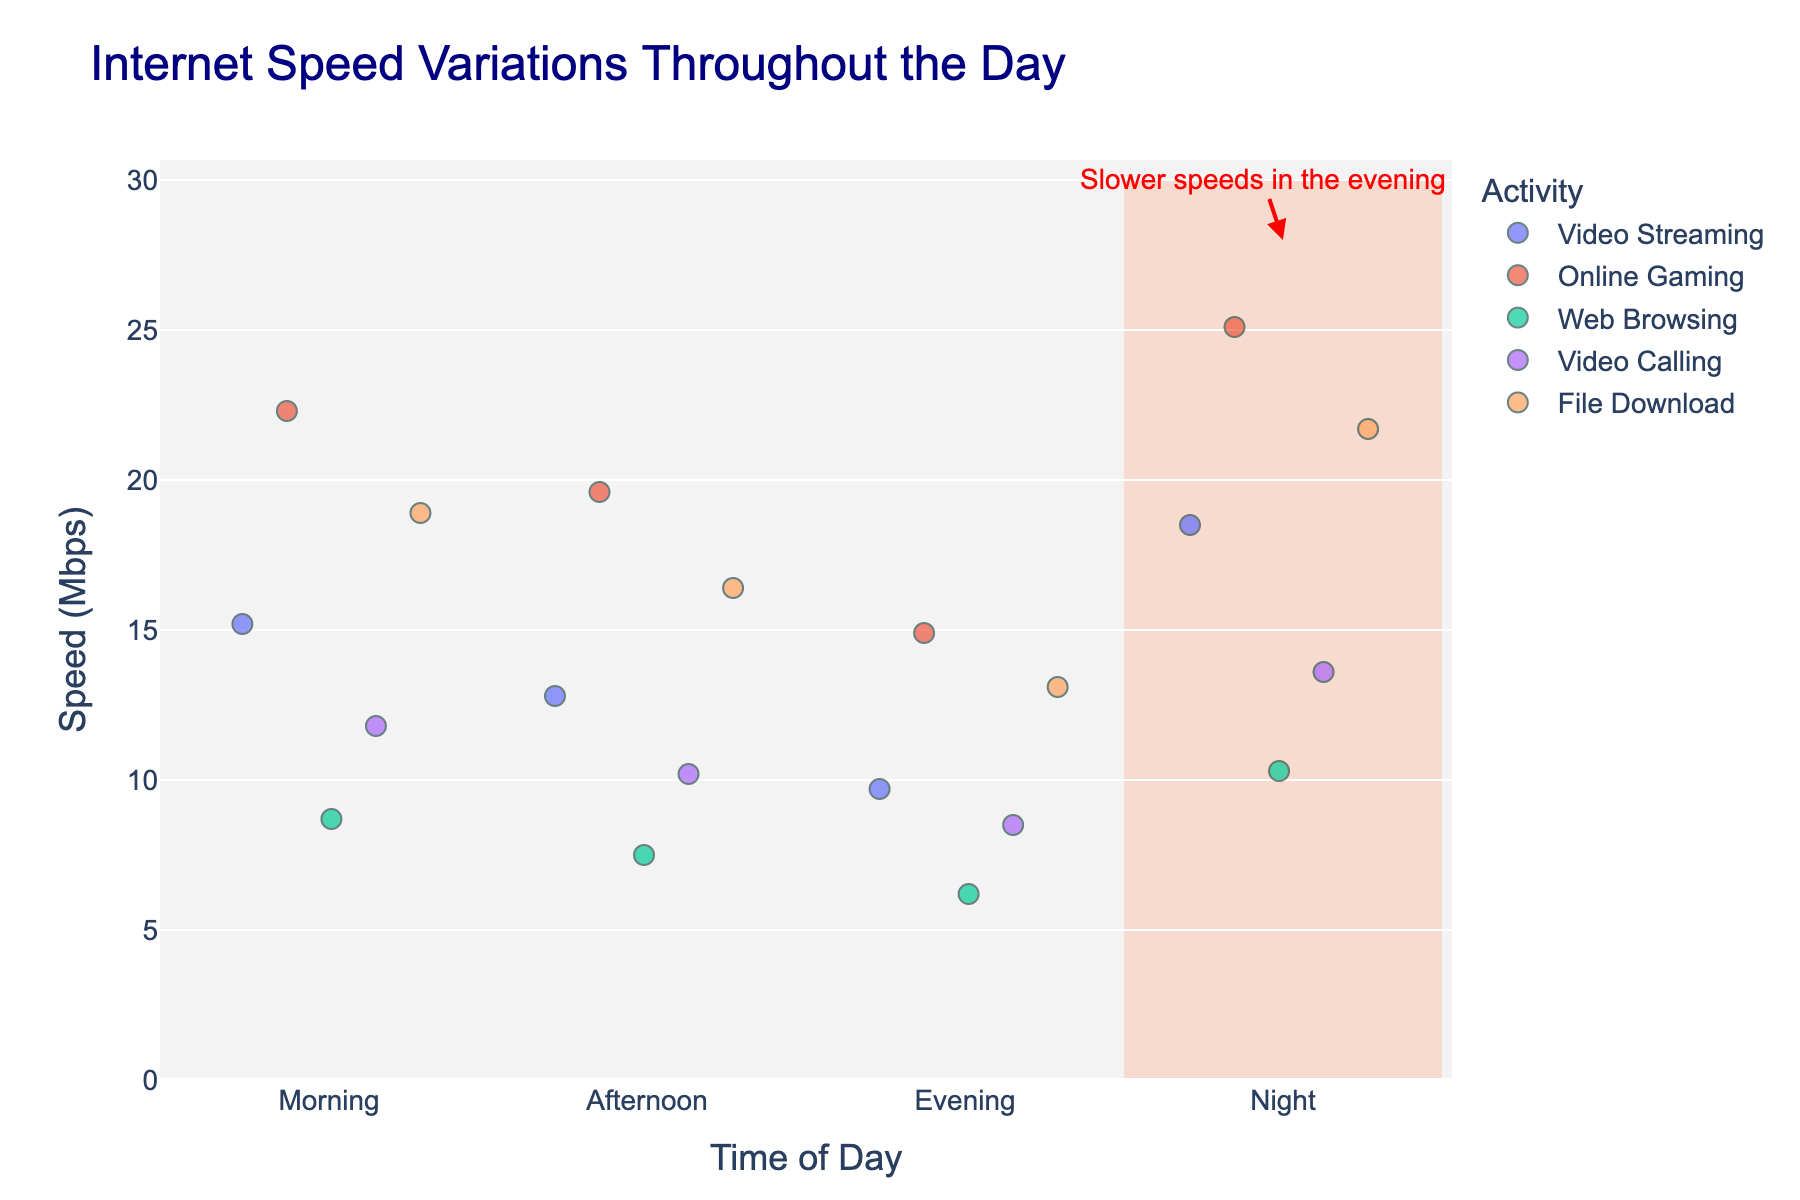what is the title of the figure? The title of the figure is given at the top, and reading it reveals it is "Internet Speed Variations Throughout the Day"
Answer: Internet Speed Variations Throughout the Day What time of day do video calls generally have the slowest speed? Observing the video calling data points, the lowest speed, around 8.5 Mbps, occurs in the evening.
Answer: Evening How many activities are displayed on the figure? Looking at the legend and the number of unique colors/shapes, five activities can be identified: Video Streaming, Online Gaming, Web Browsing, Video Calling, and File Download.
Answer: Five At what time is internet speed generally the highest for online gaming? Observing the online gaming data points, the highest speed, around 25.1 Mbps, occurs at night.
Answer: Night What is the average internet speed for web browsing across all times of day? The speeds for web browsing are 8.7, 7.5, 6.2, and 10.3 Mbps. Summing these values: 8.7 + 7.5 + 6.2 + 10.3 = 32.7. Dividing by the number of time periods (4) gives: 32.7 / 4 = 8.175
Answer: 8.175 Mbps Does video streaming have slower speeds in the evening compared to the morning? Comparing the video streaming speeds, the speed in the evening is 9.7 Mbps and in the morning is 15.2 Mbps. Since 9.7 is less than 15.2, video streaming is slower in the evening.
Answer: Yes Which activity sees the most significant speed drop from morning to evening? Calculating the speed drops: 
- Video Streaming: 15.2 - 9.7 = 5.5 
- Online Gaming: 22.3 - 14.9 = 7.4 
- Web Browsing: 8.7 - 6.2 = 2.5 
- Video Calling: 11.8 - 8.5 = 3.3 
- File Download: 18.9 - 13.1 = 5.8 
Online Gaming has the most significant drop of 7.4 Mbps.
Answer: Online Gaming During which time of day are internet speeds generally the lowest across all activities? Observing the data points, evenings show the lowest speeds generally, especially marked by several activities having their minimum speeds in this time period, such as Video Streaming (9.7), Online Gaming (14.9), Web Browsing (6.2), Video Calling (8.5), and File Download (13.1).
Answer: Evening 